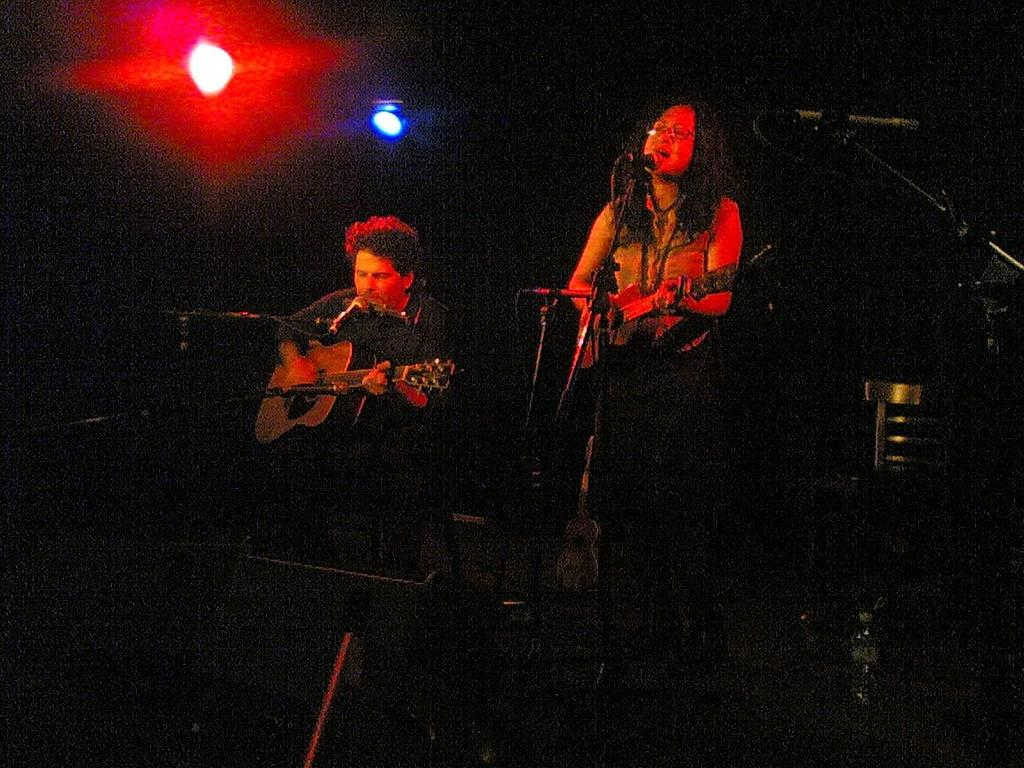What are the two people in the image doing? Both the man and woman are playing guitar in the image. What objects are present that might be used for amplifying their voices? There are microphones (mikes) in the image. What can be seen that might provide illumination? There are lights in the image. What type of stamp can be seen on the woman's guitar in the image? There is no stamp visible on the woman's guitar in the image. What kind of jewel is the man wearing on his neck in the image? There is no jewel visible on the man's neck in the image. 